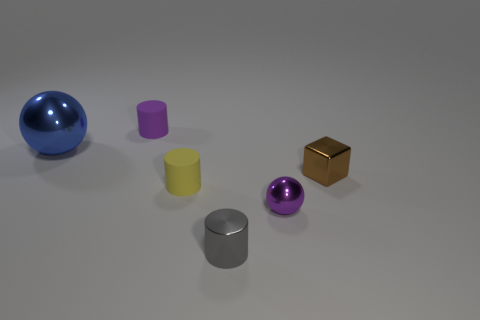Add 4 small brown matte cubes. How many objects exist? 10 Subtract all balls. How many objects are left? 4 Add 3 tiny metal balls. How many tiny metal balls exist? 4 Subtract 0 cyan blocks. How many objects are left? 6 Subtract all big red spheres. Subtract all small brown metallic cubes. How many objects are left? 5 Add 5 big blue balls. How many big blue balls are left? 6 